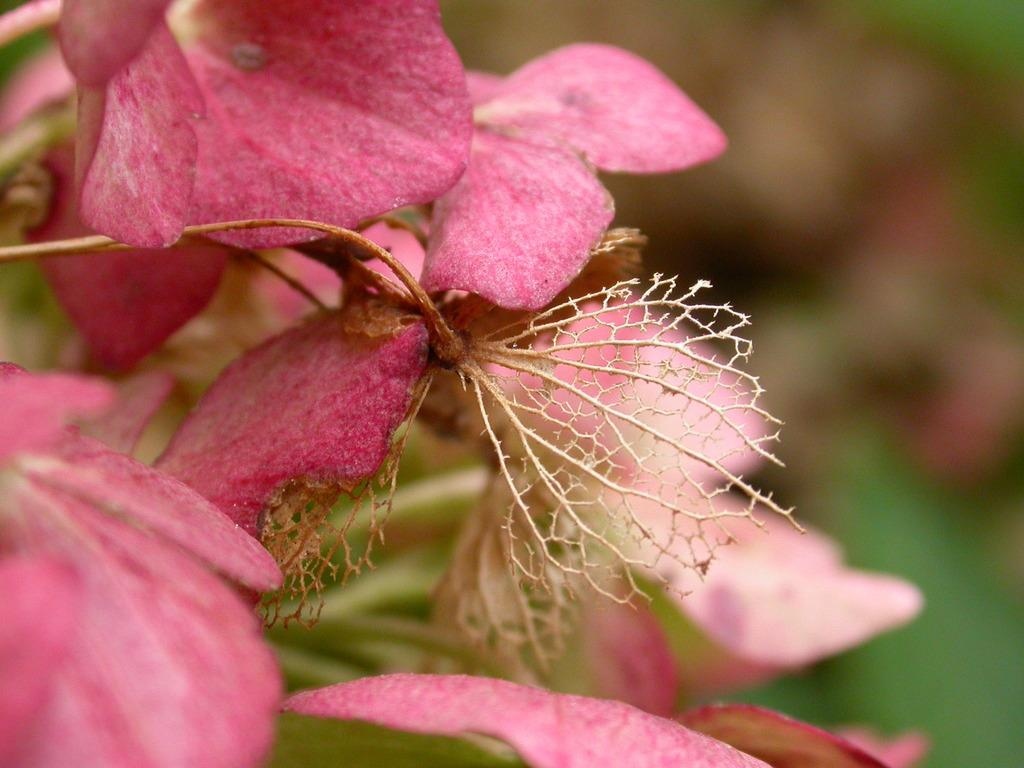What type of plants can be seen in the image? There are flowers and leaves in the image. Can you describe the appearance of the flowers? Unfortunately, the specific appearance of the flowers cannot be determined from the provided facts. What else is present in the image besides the flowers and leaves? Based on the given facts, there is no additional information about other elements in the image. What type of furniture is visible in the image? There is no furniture present in the image; it only contains flowers and leaves. Can you describe the veins on the rock in the image? There is no rock present in the image, and therefore no veins can be observed. 